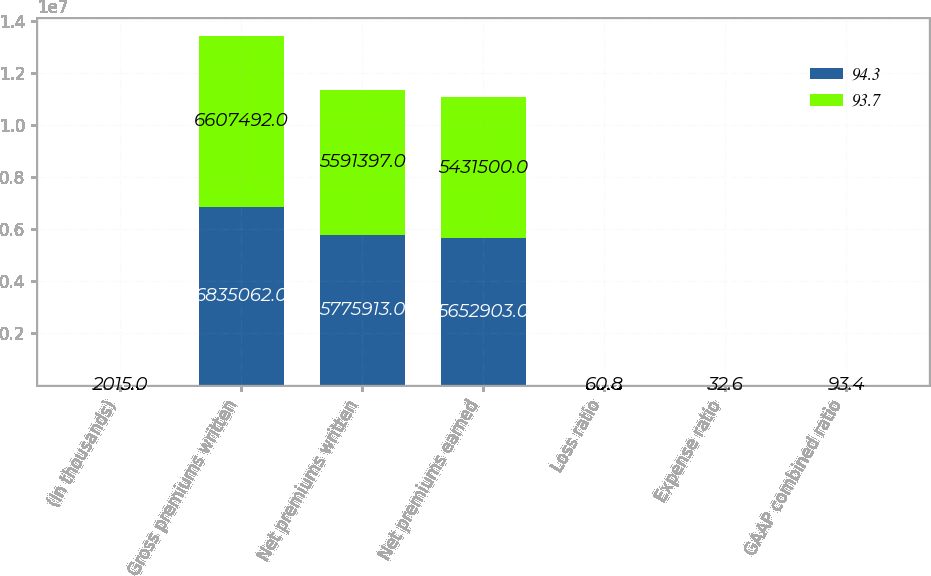Convert chart. <chart><loc_0><loc_0><loc_500><loc_500><stacked_bar_chart><ecel><fcel>(In thousands)<fcel>Gross premiums written<fcel>Net premiums written<fcel>Net premiums earned<fcel>Loss ratio<fcel>Expense ratio<fcel>GAAP combined ratio<nl><fcel>94.3<fcel>2016<fcel>6.83506e+06<fcel>5.77591e+06<fcel>5.6529e+06<fcel>61<fcel>32.6<fcel>93.6<nl><fcel>93.7<fcel>2015<fcel>6.60749e+06<fcel>5.5914e+06<fcel>5.4315e+06<fcel>60.8<fcel>32.6<fcel>93.4<nl></chart> 